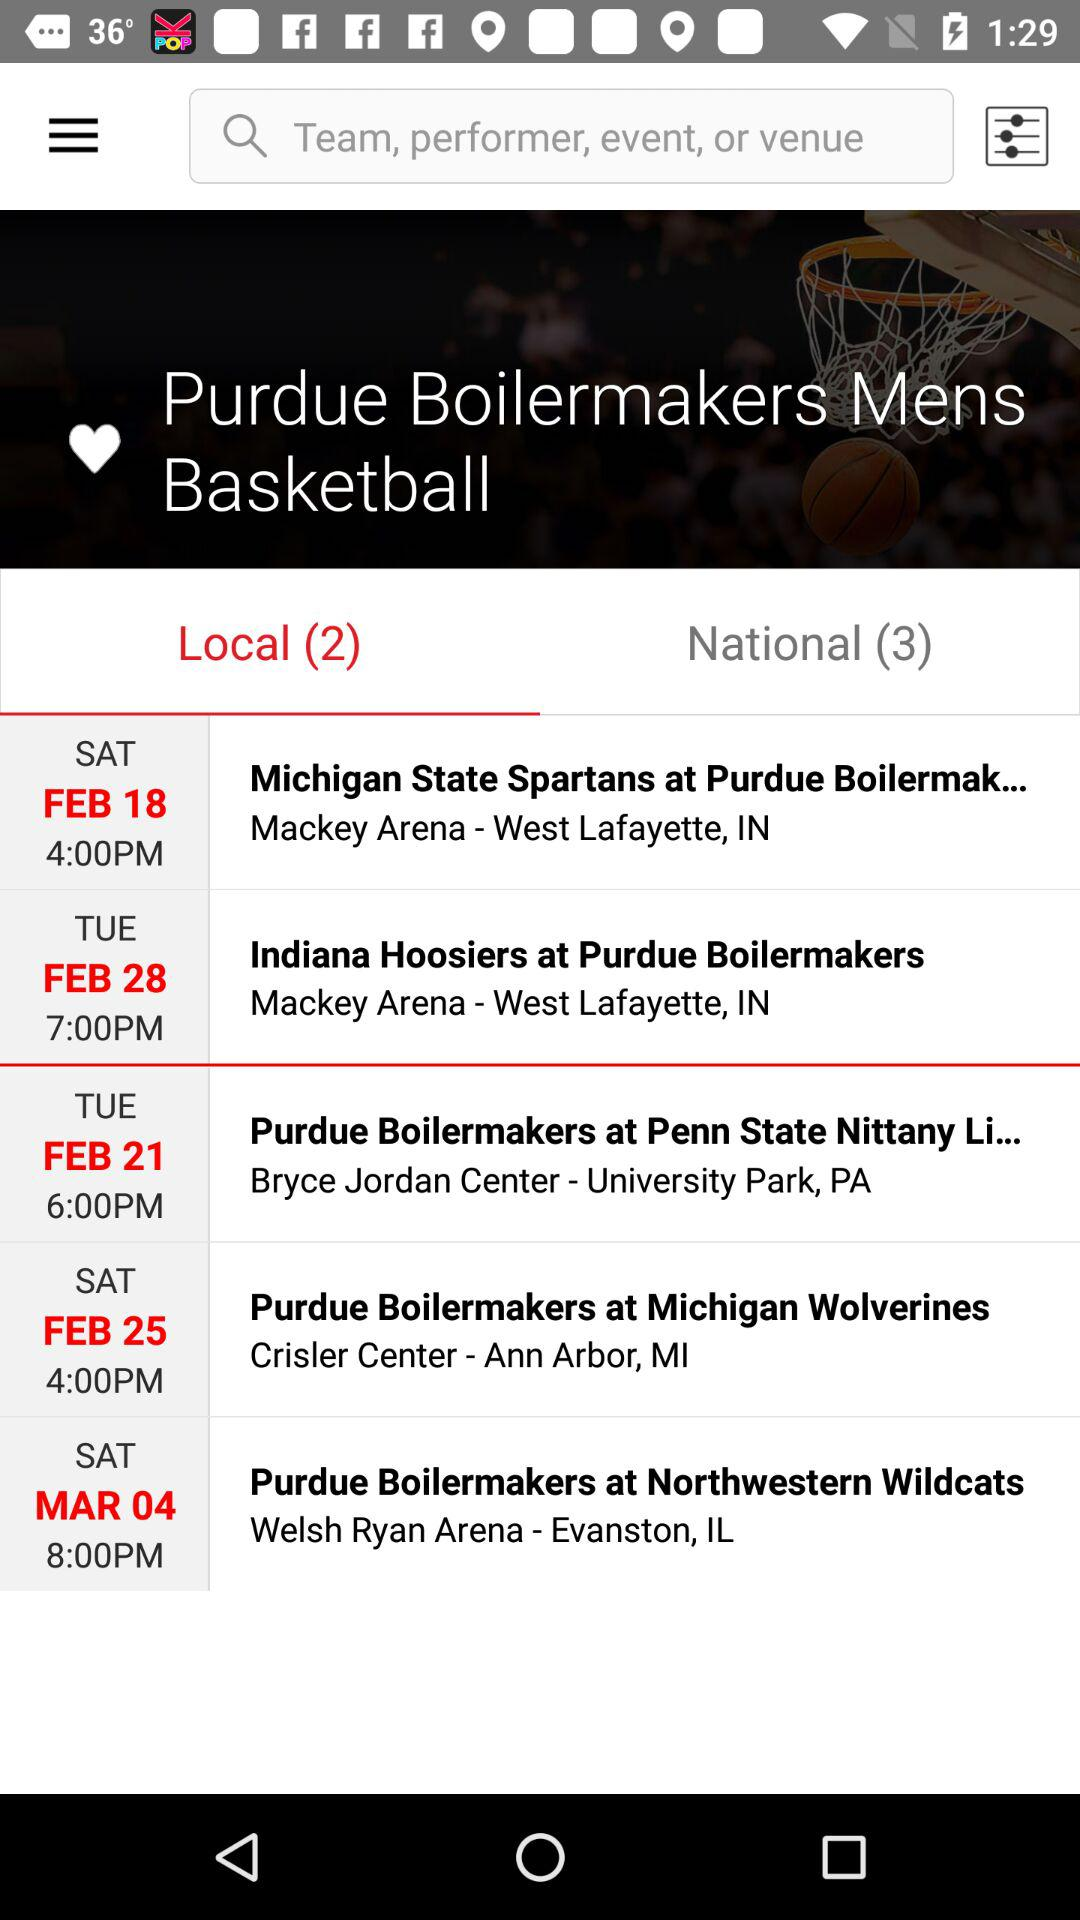Where is the venue of the "Indiana Hoosiers at Purdue Boilermakers" match? The venue of the "Indiana Hoosiers at Purdue Boilermakers" match is Mackey Arena in West Lafayette, IN. 